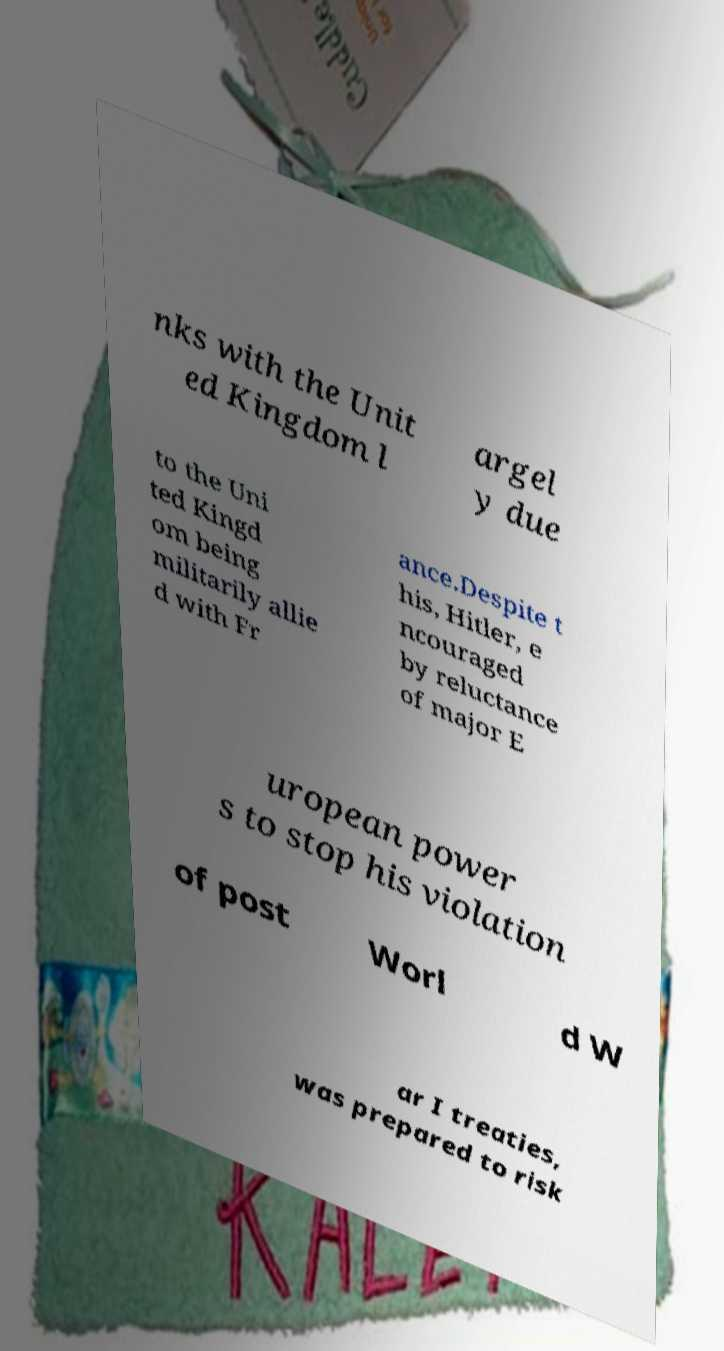Can you accurately transcribe the text from the provided image for me? nks with the Unit ed Kingdom l argel y due to the Uni ted Kingd om being militarily allie d with Fr ance.Despite t his, Hitler, e ncouraged by reluctance of major E uropean power s to stop his violation of post Worl d W ar I treaties, was prepared to risk 